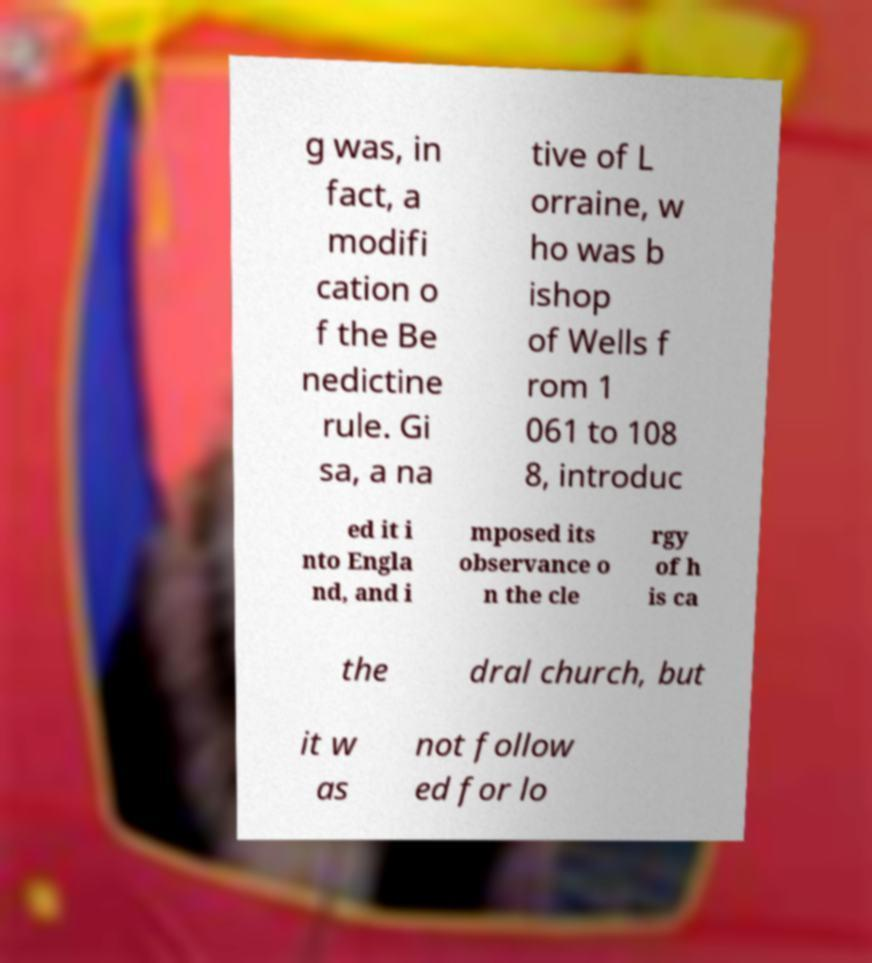Can you read and provide the text displayed in the image?This photo seems to have some interesting text. Can you extract and type it out for me? g was, in fact, a modifi cation o f the Be nedictine rule. Gi sa, a na tive of L orraine, w ho was b ishop of Wells f rom 1 061 to 108 8, introduc ed it i nto Engla nd, and i mposed its observance o n the cle rgy of h is ca the dral church, but it w as not follow ed for lo 